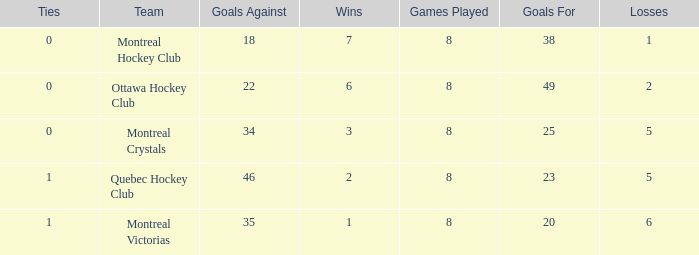What is the overall sum of goals when there are over 0 ties, more than 35 goals against, and fewer than 2 wins? 0.0. Could you help me parse every detail presented in this table? {'header': ['Ties', 'Team', 'Goals Against', 'Wins', 'Games Played', 'Goals For', 'Losses'], 'rows': [['0', 'Montreal Hockey Club', '18', '7', '8', '38', '1'], ['0', 'Ottawa Hockey Club', '22', '6', '8', '49', '2'], ['0', 'Montreal Crystals', '34', '3', '8', '25', '5'], ['1', 'Quebec Hockey Club', '46', '2', '8', '23', '5'], ['1', 'Montreal Victorias', '35', '1', '8', '20', '6']]} 